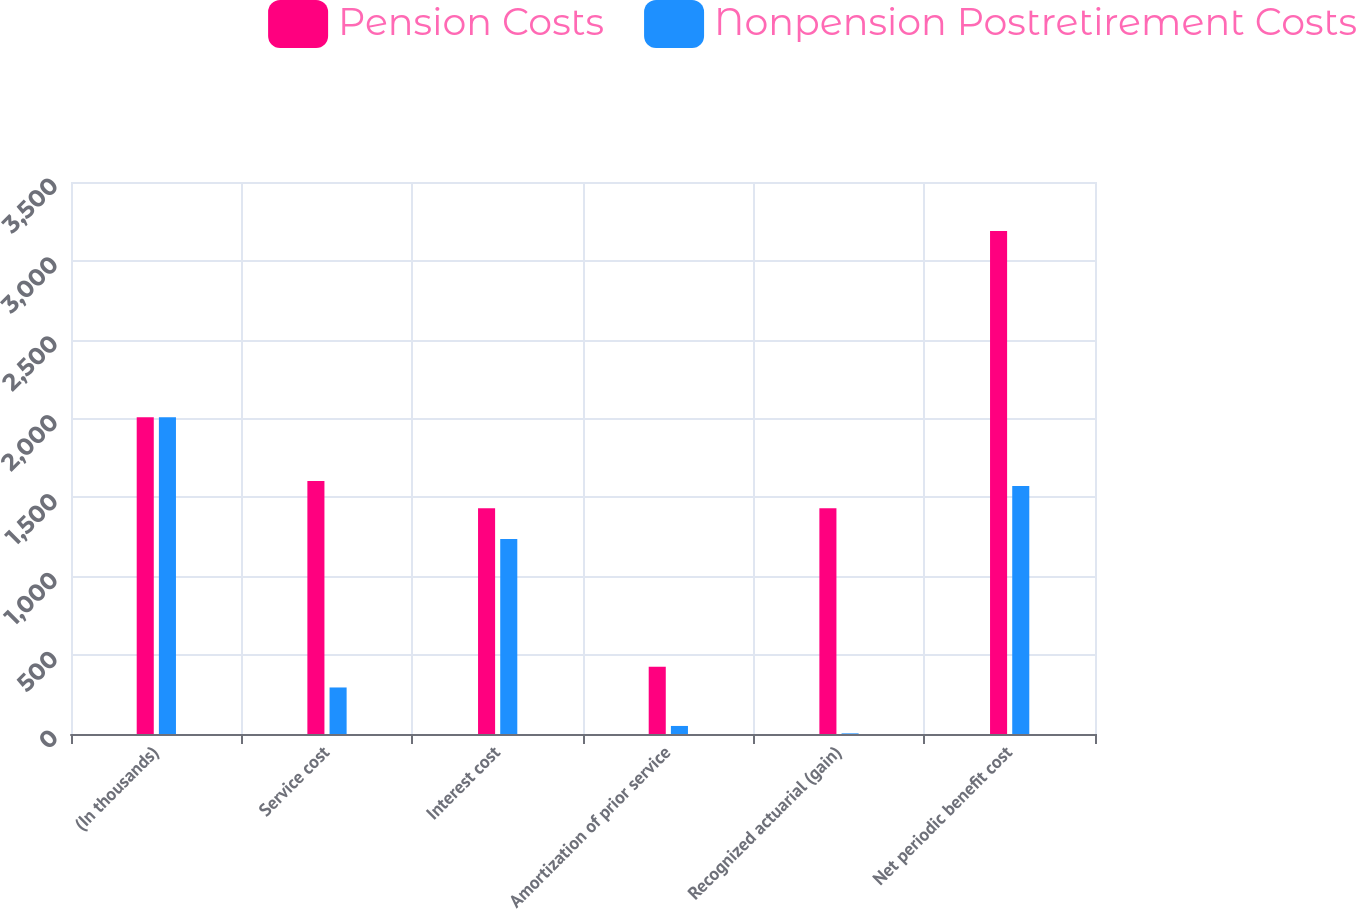<chart> <loc_0><loc_0><loc_500><loc_500><stacked_bar_chart><ecel><fcel>(In thousands)<fcel>Service cost<fcel>Interest cost<fcel>Amortization of prior service<fcel>Recognized actuarial (gain)<fcel>Net periodic benefit cost<nl><fcel>Pension Costs<fcel>2009<fcel>1604<fcel>1432<fcel>426<fcel>1432<fcel>3190<nl><fcel>Nonpension Postretirement Costs<fcel>2009<fcel>295<fcel>1237<fcel>51<fcel>4<fcel>1572<nl></chart> 